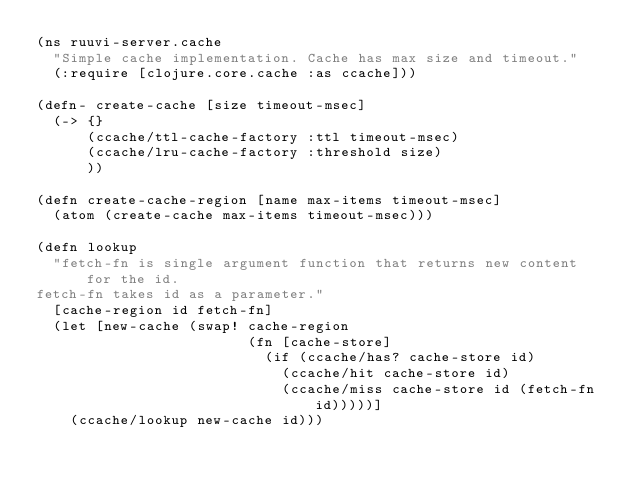<code> <loc_0><loc_0><loc_500><loc_500><_Clojure_>(ns ruuvi-server.cache
  "Simple cache implementation. Cache has max size and timeout."
  (:require [clojure.core.cache :as ccache]))

(defn- create-cache [size timeout-msec]
  (-> {}
      (ccache/ttl-cache-factory :ttl timeout-msec)
      (ccache/lru-cache-factory :threshold size)
      ))

(defn create-cache-region [name max-items timeout-msec]
  (atom (create-cache max-items timeout-msec)))

(defn lookup
  "fetch-fn is single argument function that returns new content for the id.
fetch-fn takes id as a parameter."
  [cache-region id fetch-fn]
  (let [new-cache (swap! cache-region
                         (fn [cache-store]
                           (if (ccache/has? cache-store id)
                             (ccache/hit cache-store id)
                             (ccache/miss cache-store id (fetch-fn id)))))]
    (ccache/lookup new-cache id)))</code> 